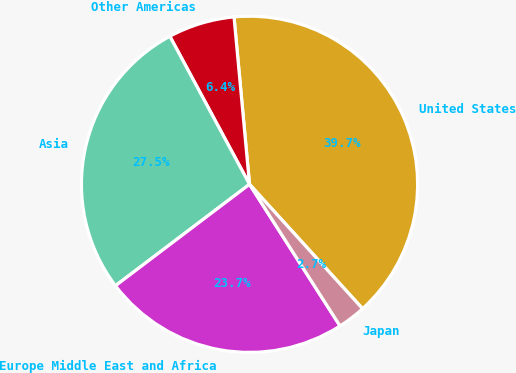<chart> <loc_0><loc_0><loc_500><loc_500><pie_chart><fcel>United States<fcel>Other Americas<fcel>Asia<fcel>Europe Middle East and Africa<fcel>Japan<nl><fcel>39.73%<fcel>6.39%<fcel>27.45%<fcel>23.74%<fcel>2.69%<nl></chart> 